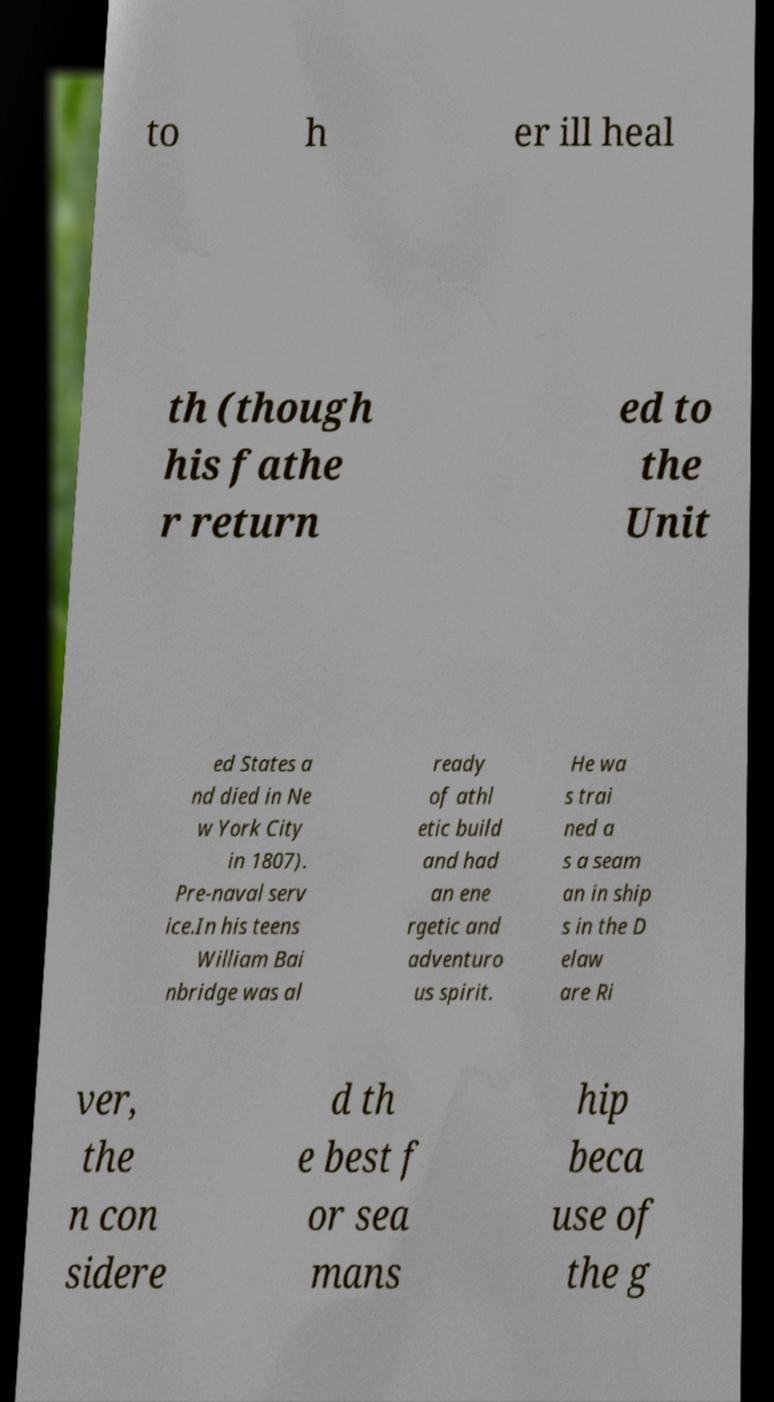What messages or text are displayed in this image? I need them in a readable, typed format. to h er ill heal th (though his fathe r return ed to the Unit ed States a nd died in Ne w York City in 1807). Pre-naval serv ice.In his teens William Bai nbridge was al ready of athl etic build and had an ene rgetic and adventuro us spirit. He wa s trai ned a s a seam an in ship s in the D elaw are Ri ver, the n con sidere d th e best f or sea mans hip beca use of the g 